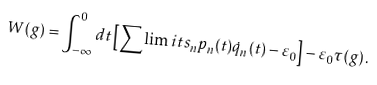Convert formula to latex. <formula><loc_0><loc_0><loc_500><loc_500>W ( g ) = \int _ { - \infty } ^ { 0 } d t \left [ \sum \lim i t s _ { n } p _ { n } ( t ) \dot { q } _ { n } ( t ) - \varepsilon _ { 0 } \right ] - \varepsilon _ { 0 } \tau ( g ) \, .</formula> 